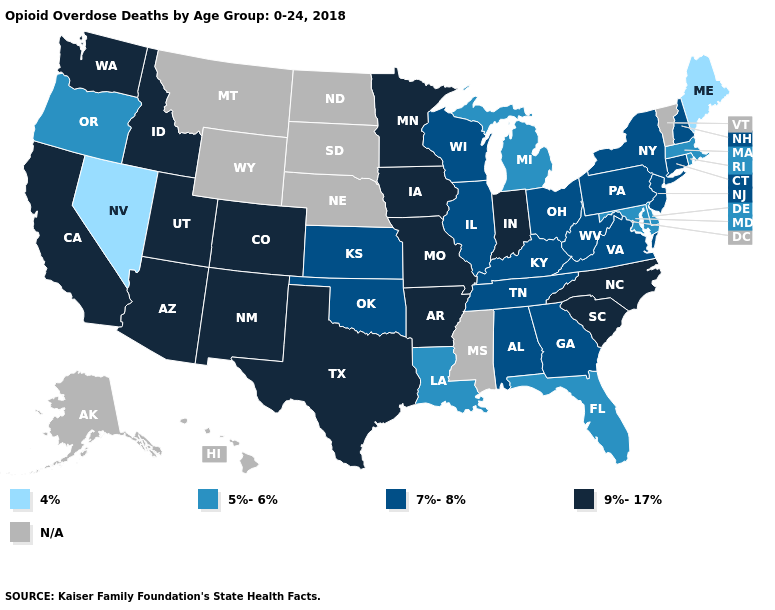Does Kentucky have the lowest value in the South?
Keep it brief. No. What is the value of Mississippi?
Short answer required. N/A. Name the states that have a value in the range 7%-8%?
Give a very brief answer. Alabama, Connecticut, Georgia, Illinois, Kansas, Kentucky, New Hampshire, New Jersey, New York, Ohio, Oklahoma, Pennsylvania, Tennessee, Virginia, West Virginia, Wisconsin. What is the lowest value in the USA?
Give a very brief answer. 4%. Does Oregon have the highest value in the West?
Write a very short answer. No. Among the states that border Colorado , which have the highest value?
Give a very brief answer. Arizona, New Mexico, Utah. Does the map have missing data?
Keep it brief. Yes. What is the value of Nebraska?
Concise answer only. N/A. What is the highest value in the USA?
Keep it brief. 9%-17%. Is the legend a continuous bar?
Quick response, please. No. Does the first symbol in the legend represent the smallest category?
Be succinct. Yes. Name the states that have a value in the range 4%?
Write a very short answer. Maine, Nevada. Does the map have missing data?
Write a very short answer. Yes. Does the first symbol in the legend represent the smallest category?
Be succinct. Yes. What is the value of Colorado?
Keep it brief. 9%-17%. 